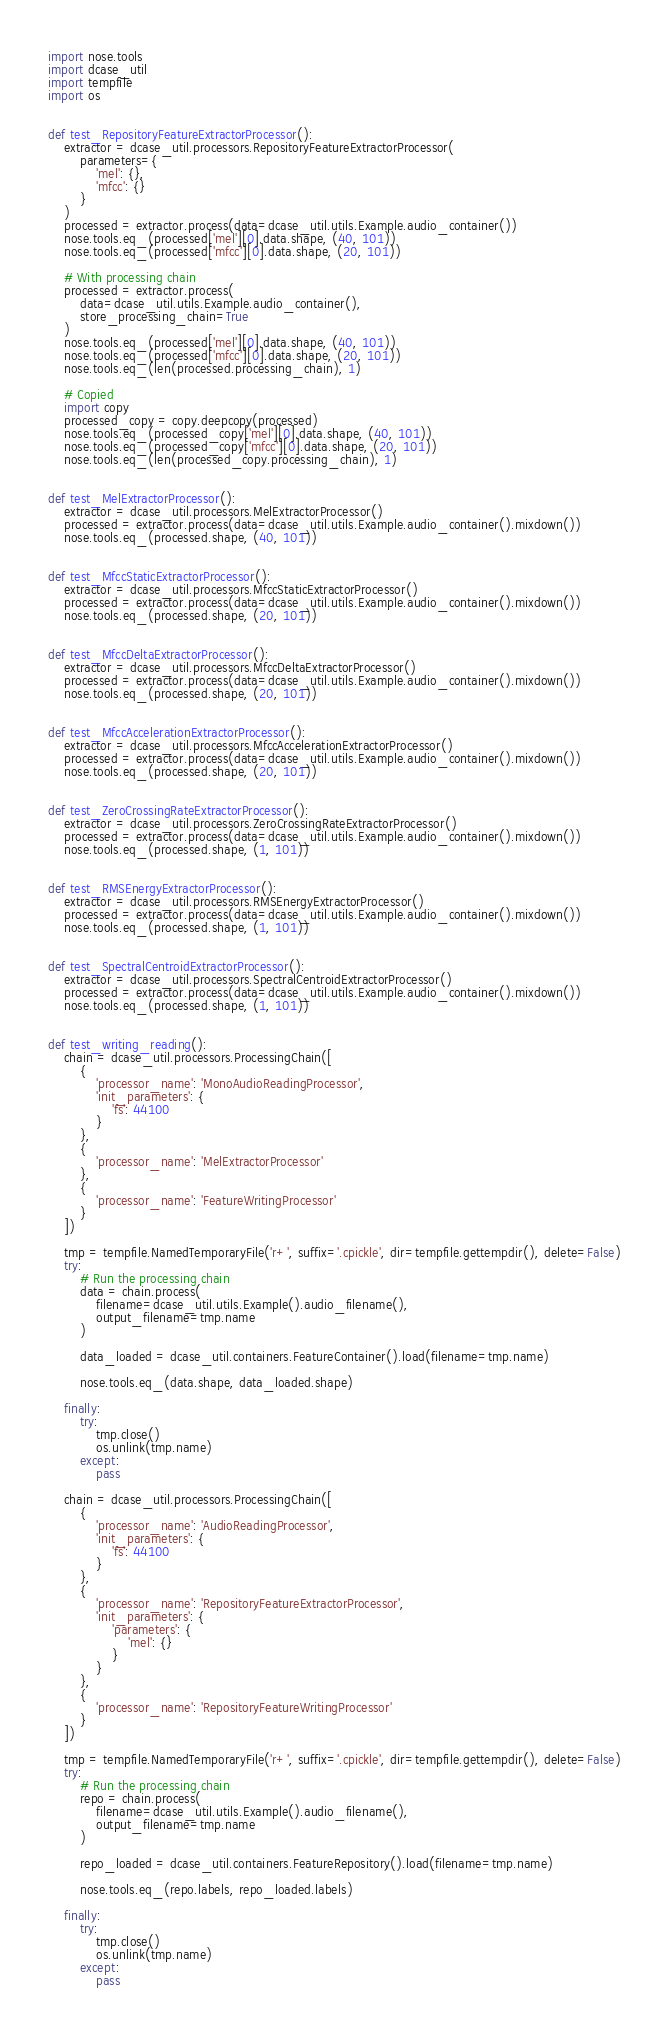Convert code to text. <code><loc_0><loc_0><loc_500><loc_500><_Python_>import nose.tools
import dcase_util
import tempfile
import os


def test_RepositoryFeatureExtractorProcessor():
    extractor = dcase_util.processors.RepositoryFeatureExtractorProcessor(
        parameters={
            'mel': {},
            'mfcc': {}
        }
    )
    processed = extractor.process(data=dcase_util.utils.Example.audio_container())
    nose.tools.eq_(processed['mel'][0].data.shape, (40, 101))
    nose.tools.eq_(processed['mfcc'][0].data.shape, (20, 101))

    # With processing chain
    processed = extractor.process(
        data=dcase_util.utils.Example.audio_container(),
        store_processing_chain=True
    )
    nose.tools.eq_(processed['mel'][0].data.shape, (40, 101))
    nose.tools.eq_(processed['mfcc'][0].data.shape, (20, 101))
    nose.tools.eq_(len(processed.processing_chain), 1)

    # Copied
    import copy
    processed_copy = copy.deepcopy(processed)
    nose.tools.eq_(processed_copy['mel'][0].data.shape, (40, 101))
    nose.tools.eq_(processed_copy['mfcc'][0].data.shape, (20, 101))
    nose.tools.eq_(len(processed_copy.processing_chain), 1)


def test_MelExtractorProcessor():
    extractor = dcase_util.processors.MelExtractorProcessor()
    processed = extractor.process(data=dcase_util.utils.Example.audio_container().mixdown())
    nose.tools.eq_(processed.shape, (40, 101))


def test_MfccStaticExtractorProcessor():
    extractor = dcase_util.processors.MfccStaticExtractorProcessor()
    processed = extractor.process(data=dcase_util.utils.Example.audio_container().mixdown())
    nose.tools.eq_(processed.shape, (20, 101))


def test_MfccDeltaExtractorProcessor():
    extractor = dcase_util.processors.MfccDeltaExtractorProcessor()
    processed = extractor.process(data=dcase_util.utils.Example.audio_container().mixdown())
    nose.tools.eq_(processed.shape, (20, 101))


def test_MfccAccelerationExtractorProcessor():
    extractor = dcase_util.processors.MfccAccelerationExtractorProcessor()
    processed = extractor.process(data=dcase_util.utils.Example.audio_container().mixdown())
    nose.tools.eq_(processed.shape, (20, 101))


def test_ZeroCrossingRateExtractorProcessor():
    extractor = dcase_util.processors.ZeroCrossingRateExtractorProcessor()
    processed = extractor.process(data=dcase_util.utils.Example.audio_container().mixdown())
    nose.tools.eq_(processed.shape, (1, 101))


def test_RMSEnergyExtractorProcessor():
    extractor = dcase_util.processors.RMSEnergyExtractorProcessor()
    processed = extractor.process(data=dcase_util.utils.Example.audio_container().mixdown())
    nose.tools.eq_(processed.shape, (1, 101))


def test_SpectralCentroidExtractorProcessor():
    extractor = dcase_util.processors.SpectralCentroidExtractorProcessor()
    processed = extractor.process(data=dcase_util.utils.Example.audio_container().mixdown())
    nose.tools.eq_(processed.shape, (1, 101))


def test_writing_reading():
    chain = dcase_util.processors.ProcessingChain([
        {
            'processor_name': 'MonoAudioReadingProcessor',
            'init_parameters': {
                'fs': 44100
            }
        },
        {
            'processor_name': 'MelExtractorProcessor'
        },
        {
            'processor_name': 'FeatureWritingProcessor'
        }
    ])

    tmp = tempfile.NamedTemporaryFile('r+', suffix='.cpickle', dir=tempfile.gettempdir(), delete=False)
    try:
        # Run the processing chain
        data = chain.process(
            filename=dcase_util.utils.Example().audio_filename(),
            output_filename=tmp.name
        )

        data_loaded = dcase_util.containers.FeatureContainer().load(filename=tmp.name)

        nose.tools.eq_(data.shape, data_loaded.shape)

    finally:
        try:
            tmp.close()
            os.unlink(tmp.name)
        except:
            pass

    chain = dcase_util.processors.ProcessingChain([
        {
            'processor_name': 'AudioReadingProcessor',
            'init_parameters': {
                'fs': 44100
            }
        },
        {
            'processor_name': 'RepositoryFeatureExtractorProcessor',
            'init_parameters': {
                'parameters': {
                    'mel': {}
                }
            }
        },
        {
            'processor_name': 'RepositoryFeatureWritingProcessor'
        }
    ])

    tmp = tempfile.NamedTemporaryFile('r+', suffix='.cpickle', dir=tempfile.gettempdir(), delete=False)
    try:
        # Run the processing chain
        repo = chain.process(
            filename=dcase_util.utils.Example().audio_filename(),
            output_filename=tmp.name
        )

        repo_loaded = dcase_util.containers.FeatureRepository().load(filename=tmp.name)

        nose.tools.eq_(repo.labels, repo_loaded.labels)

    finally:
        try:
            tmp.close()
            os.unlink(tmp.name)
        except:
            pass

</code> 